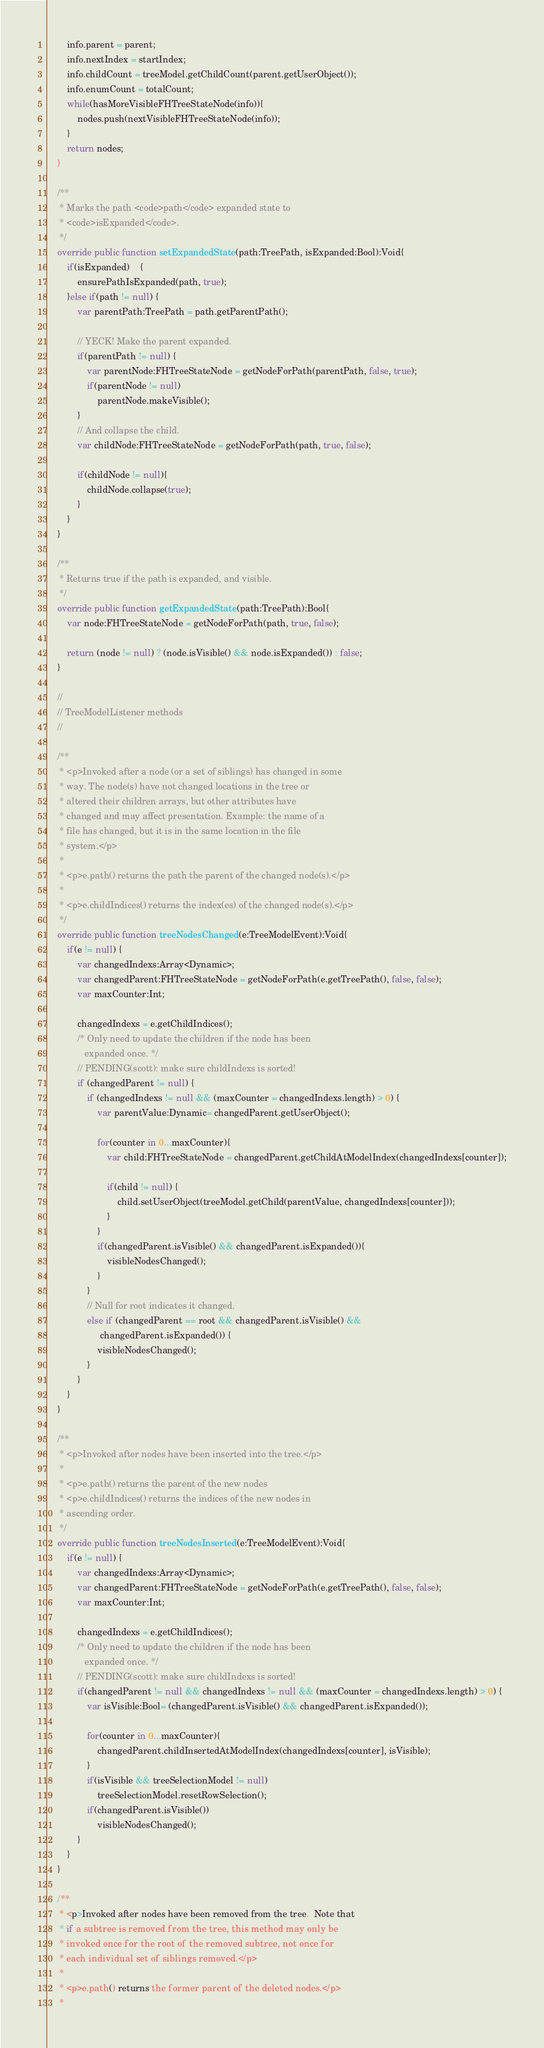<code> <loc_0><loc_0><loc_500><loc_500><_Haxe_>		info.parent = parent;
		info.nextIndex = startIndex;
		info.childCount = treeModel.getChildCount(parent.getUserObject());
		info.enumCount = totalCount;
		while(hasMoreVisibleFHTreeStateNode(info)){
			nodes.push(nextVisibleFHTreeStateNode(info));
		}
		return nodes;
	}

	/**
	 * Marks the path <code>path</code> expanded state to
	 * <code>isExpanded</code>.
	 */
	override public function setExpandedState(path:TreePath, isExpanded:Bool):Void{
		if(isExpanded)	{
			ensurePathIsExpanded(path, true);
		}else if(path != null) {
			var parentPath:TreePath = path.getParentPath();
	
			// YECK! Make the parent expanded.
			if(parentPath != null) {
				var parentNode:FHTreeStateNode = getNodeForPath(parentPath, false, true);
				if(parentNode != null)
					parentNode.makeVisible();
			}
			// And collapse the child.
			var childNode:FHTreeStateNode = getNodeForPath(path, true, false);
	
			if(childNode != null){
				childNode.collapse(true);
			}
		}
	}

	/**
	 * Returns true if the path is expanded, and visible.
	 */
	override public function getExpandedState(path:TreePath):Bool{
		var node:FHTreeStateNode = getNodeForPath(path, true, false);
	
		return (node != null) ? (node.isVisible() && node.isExpanded()) : false;
	}

	//
	// TreeModelListener methods
	//

	/**
	 * <p>Invoked after a node (or a set of siblings) has changed in some
	 * way. The node(s) have not changed locations in the tree or
	 * altered their children arrays, but other attributes have
	 * changed and may affect presentation. Example: the name of a
	 * file has changed, but it is in the same location in the file
	 * system.</p>
	 *
	 * <p>e.path() returns the path the parent of the changed node(s).</p>
	 *
	 * <p>e.childIndices() returns the index(es) of the changed node(s).</p>
	 */
	override public function treeNodesChanged(e:TreeModelEvent):Void{
		if(e != null) {
			var changedIndexs:Array<Dynamic>;
			var changedParent:FHTreeStateNode = getNodeForPath(e.getTreePath(), false, false);
			var maxCounter:Int;
	
			changedIndexs = e.getChildIndices();
			/* Only need to update the children if the node has been
			   expanded once. */
			// PENDING(scott): make sure childIndexs is sorted!
			if (changedParent != null) {
				if (changedIndexs != null && (maxCounter = changedIndexs.length) > 0) {
					var parentValue:Dynamic= changedParent.getUserObject();
		
					for(counter in 0...maxCounter){
						var child:FHTreeStateNode = changedParent.getChildAtModelIndex(changedIndexs[counter]);
			
						if(child != null) {
							child.setUserObject(treeModel.getChild(parentValue, changedIndexs[counter]));
						}
					}
					if(changedParent.isVisible() && changedParent.isExpanded()){
						visibleNodesChanged();
					}
				}
				// Null for root indicates it changed.
				else if (changedParent == root && changedParent.isVisible() &&
					 changedParent.isExpanded()) {
					visibleNodesChanged();
				}
			}
		}
	}

	/**
	 * <p>Invoked after nodes have been inserted into the tree.</p>
	 *
	 * <p>e.path() returns the parent of the new nodes
	 * <p>e.childIndices() returns the indices of the new nodes in
	 * ascending order.
	 */
	override public function treeNodesInserted(e:TreeModelEvent):Void{
		if(e != null) {
			var changedIndexs:Array<Dynamic>;
			var changedParent:FHTreeStateNode = getNodeForPath(e.getTreePath(), false, false);
			var maxCounter:Int;
	
			changedIndexs = e.getChildIndices();
			/* Only need to update the children if the node has been
			   expanded once. */
			// PENDING(scott): make sure childIndexs is sorted!
			if(changedParent != null && changedIndexs != null && (maxCounter = changedIndexs.length) > 0) {
				var isVisible:Bool= (changedParent.isVisible() && changedParent.isExpanded());
		
				for(counter in 0...maxCounter){
					changedParent.childInsertedAtModelIndex(changedIndexs[counter], isVisible);
				}
				if(isVisible && treeSelectionModel != null)
					treeSelectionModel.resetRowSelection();
				if(changedParent.isVisible())
					visibleNodesChanged();
			}
		}
	}

	/**
	 * <p>Invoked after nodes have been removed from the tree.  Note that
	 * if a subtree is removed from the tree, this method may only be
	 * invoked once for the root of the removed subtree, not once for
	 * each individual set of siblings removed.</p>
	 *
	 * <p>e.path() returns the former parent of the deleted nodes.</p>
	 *</code> 